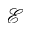Convert formula to latex. <formula><loc_0><loc_0><loc_500><loc_500>\mathcal { E }</formula> 